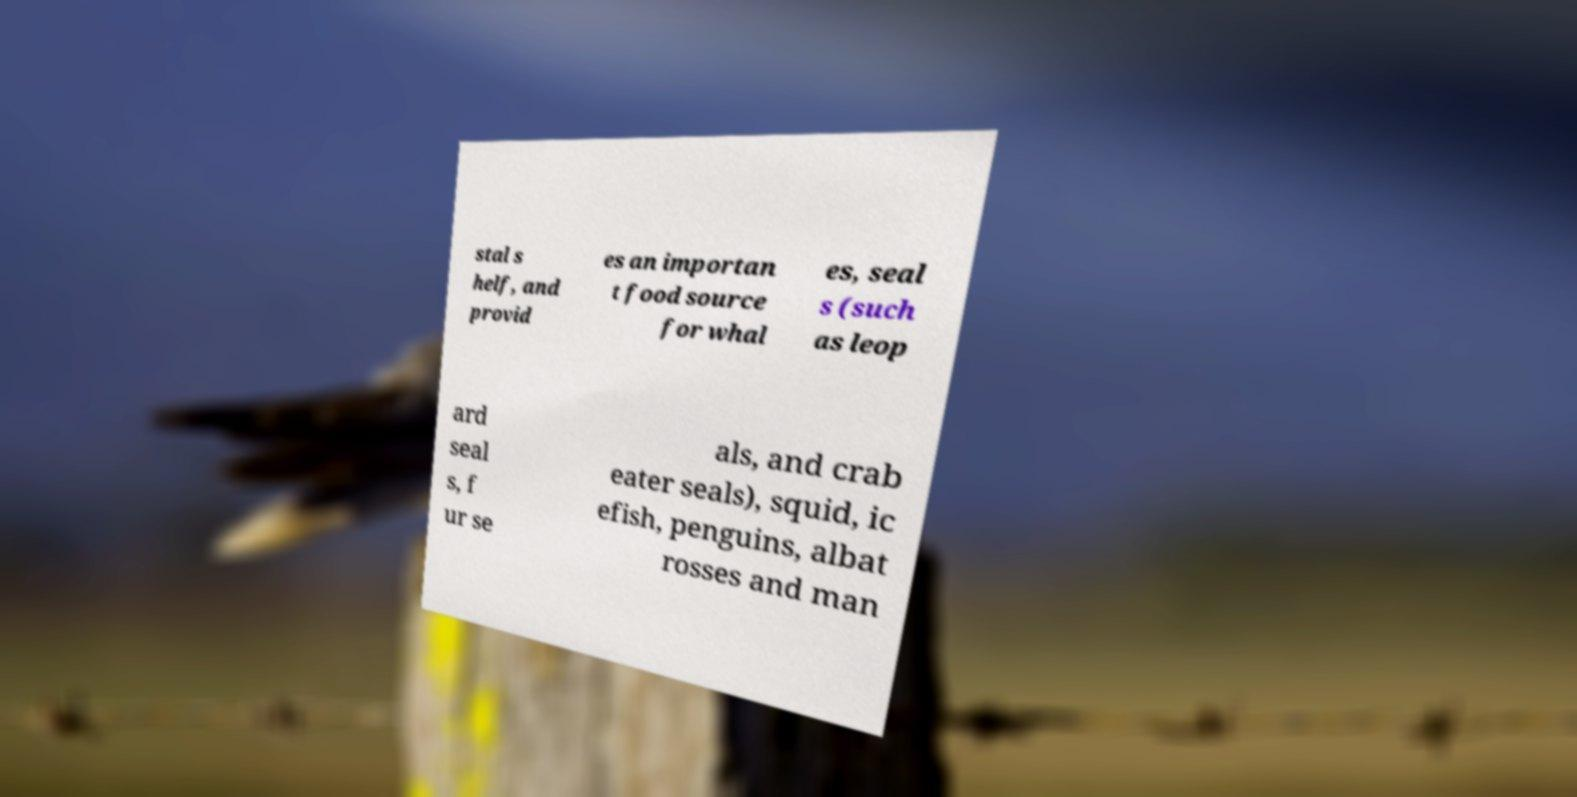For documentation purposes, I need the text within this image transcribed. Could you provide that? stal s helf, and provid es an importan t food source for whal es, seal s (such as leop ard seal s, f ur se als, and crab eater seals), squid, ic efish, penguins, albat rosses and man 